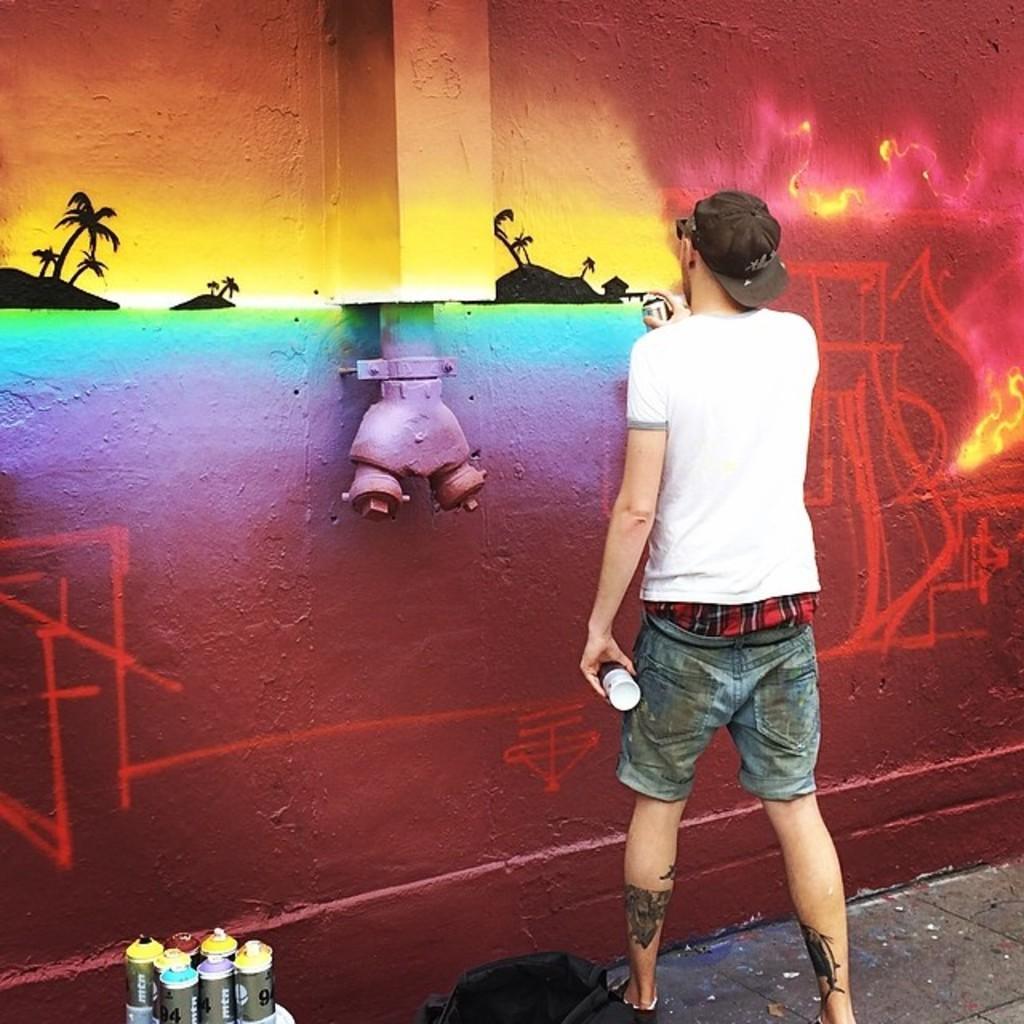In one or two sentences, can you explain what this image depicts? In this image in the center there is one person who is standing, and he is doing some graffiti. On the wall on the left side there are some graffiti containers, and there is one bag. 